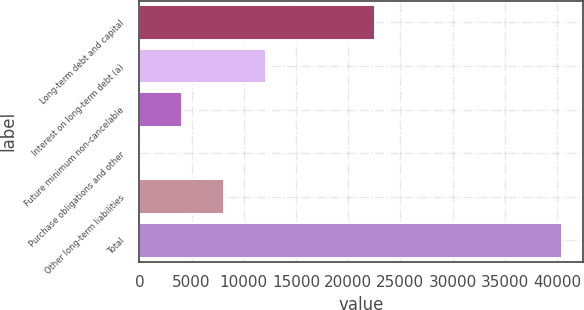<chart> <loc_0><loc_0><loc_500><loc_500><bar_chart><fcel>Long-term debt and capital<fcel>Interest on long-term debt (a)<fcel>Future minimum non-cancelable<fcel>Purchase obligations and other<fcel>Other long-term liabilities<fcel>Total<nl><fcel>22570<fcel>12132.5<fcel>4045.5<fcel>2<fcel>8089<fcel>40437<nl></chart> 